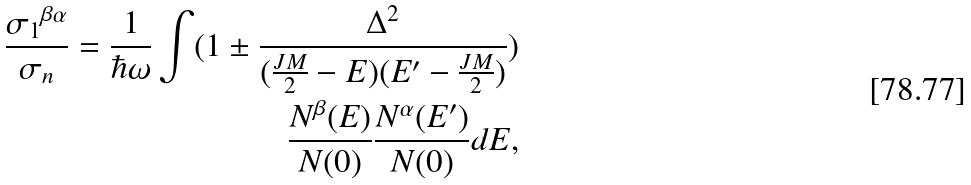<formula> <loc_0><loc_0><loc_500><loc_500>\frac { { \sigma _ { 1 } } ^ { \beta \alpha } } { \sigma _ { n } } = \frac { 1 } { \hbar { \omega } } \int ( 1 \pm \frac { \Delta ^ { 2 } } { ( \frac { J M } { 2 } - E ) ( E ^ { \prime } - \frac { J M } { 2 } ) } ) \\ \frac { N ^ { \beta } ( E ) } { N ( 0 ) } \frac { N ^ { \alpha } ( E ^ { \prime } ) } { N ( 0 ) } d E ,</formula> 